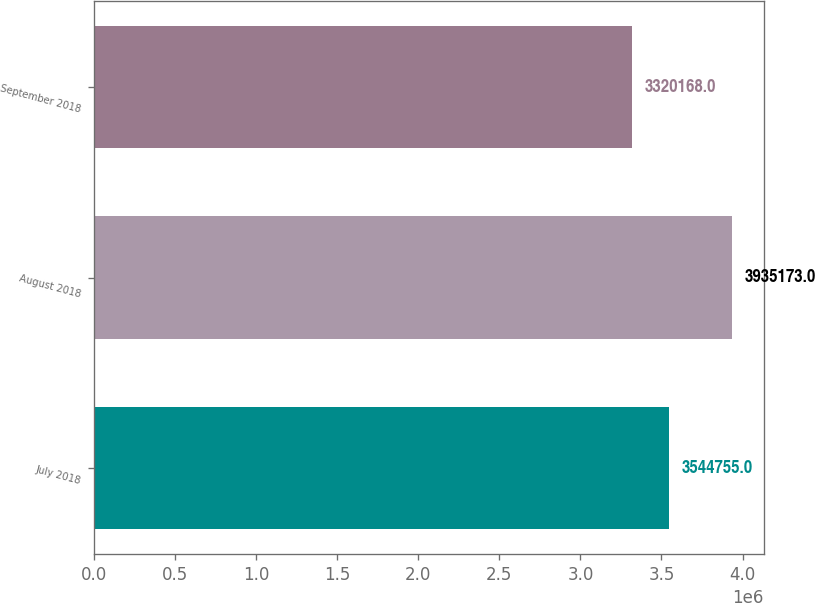<chart> <loc_0><loc_0><loc_500><loc_500><bar_chart><fcel>July 2018<fcel>August 2018<fcel>September 2018<nl><fcel>3.54476e+06<fcel>3.93517e+06<fcel>3.32017e+06<nl></chart> 